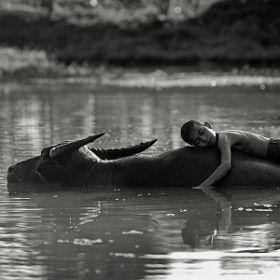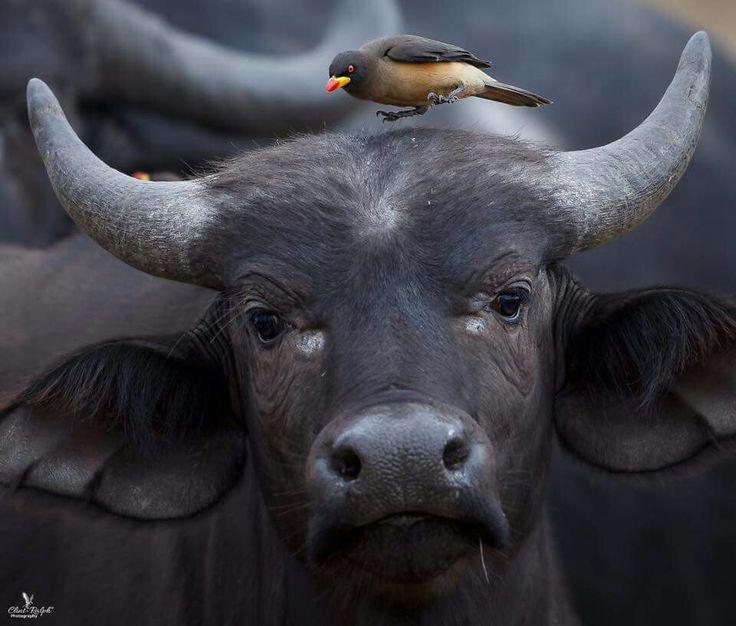The first image is the image on the left, the second image is the image on the right. Examine the images to the left and right. Is the description "There are two water buffallos wading in water." accurate? Answer yes or no. No. The first image is the image on the left, the second image is the image on the right. Examine the images to the left and right. Is the description "There is more than one animal species." accurate? Answer yes or no. Yes. 